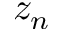Convert formula to latex. <formula><loc_0><loc_0><loc_500><loc_500>z _ { n }</formula> 